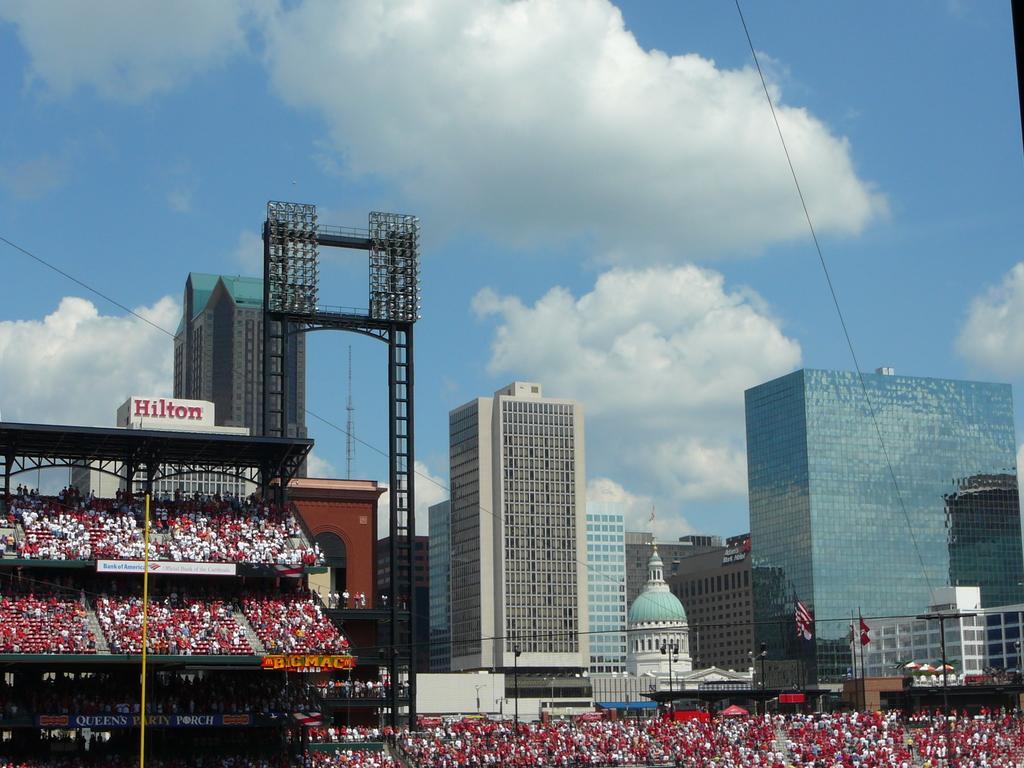Could you give a brief overview of what you see in this image? In this image there is a stadium, group of people, lights, lighting truss, buildings, flags, and in the background there is sky. 